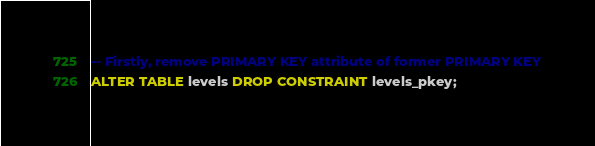<code> <loc_0><loc_0><loc_500><loc_500><_SQL_>-- Firstly, remove PRIMARY KEY attribute of former PRIMARY KEY
ALTER TABLE levels DROP CONSTRAINT levels_pkey;</code> 